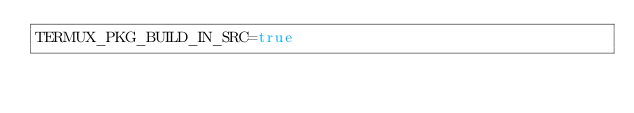Convert code to text. <code><loc_0><loc_0><loc_500><loc_500><_Bash_>TERMUX_PKG_BUILD_IN_SRC=true
</code> 